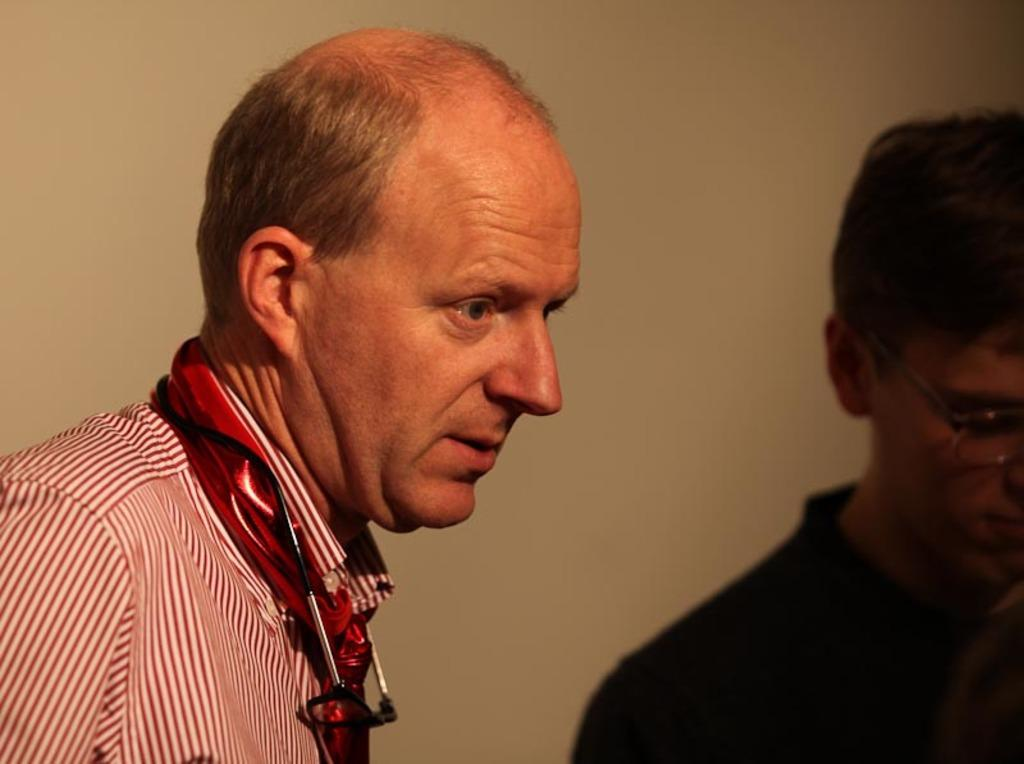How many people are present in the image? There are two people in the image, one standing on the right side and the other on the left side. What can be seen in the background of the image? There is a wall in the background of the image. What type of hate can be seen on the wall in the image? There is no hate present in the image, and the wall does not display any emotions or feelings. 